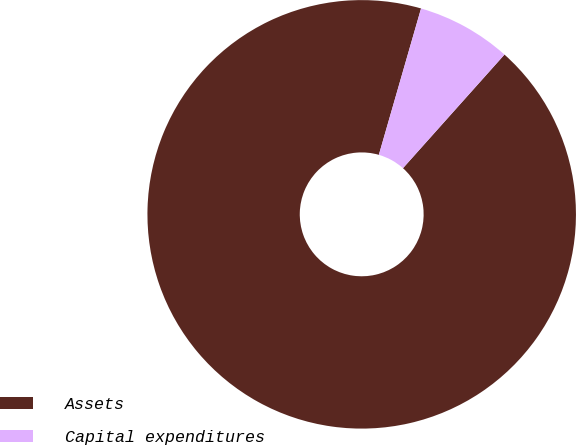<chart> <loc_0><loc_0><loc_500><loc_500><pie_chart><fcel>Assets<fcel>Capital expenditures<nl><fcel>92.86%<fcel>7.14%<nl></chart> 